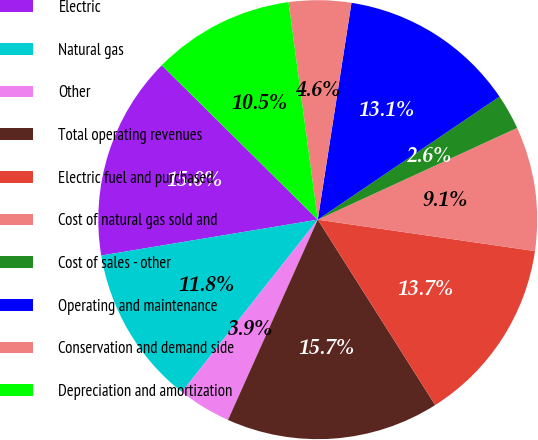Convert chart. <chart><loc_0><loc_0><loc_500><loc_500><pie_chart><fcel>Electric<fcel>Natural gas<fcel>Other<fcel>Total operating revenues<fcel>Electric fuel and purchased<fcel>Cost of natural gas sold and<fcel>Cost of sales - other<fcel>Operating and maintenance<fcel>Conservation and demand side<fcel>Depreciation and amortization<nl><fcel>15.03%<fcel>11.76%<fcel>3.92%<fcel>15.69%<fcel>13.73%<fcel>9.15%<fcel>2.61%<fcel>13.07%<fcel>4.58%<fcel>10.46%<nl></chart> 